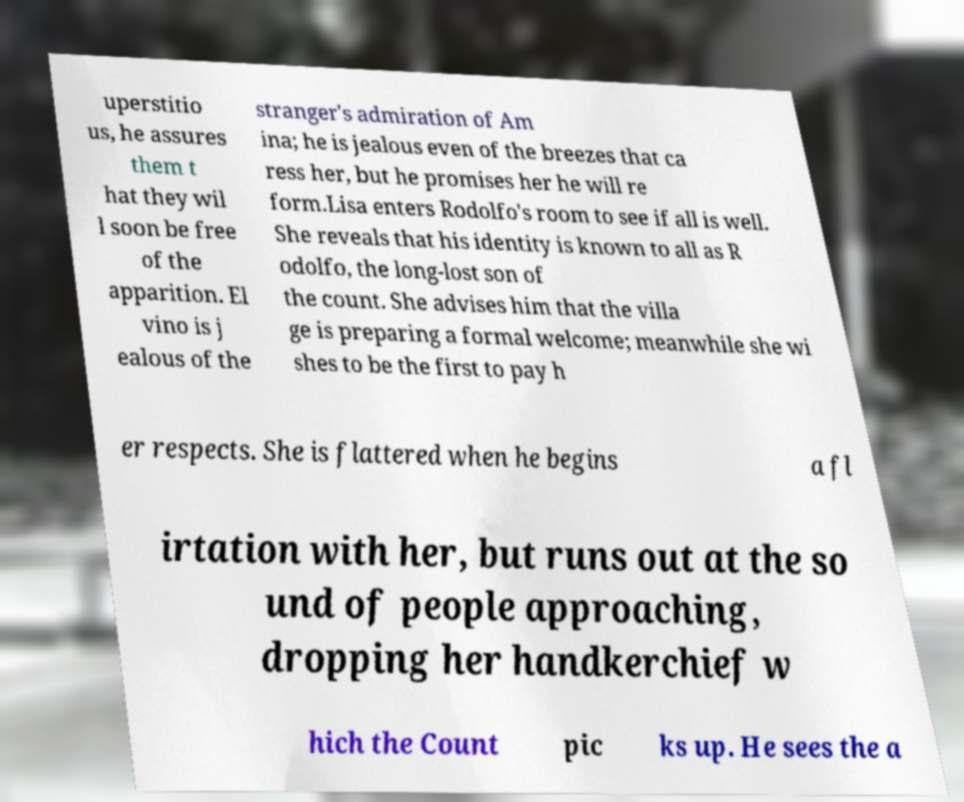Could you extract and type out the text from this image? uperstitio us, he assures them t hat they wil l soon be free of the apparition. El vino is j ealous of the stranger's admiration of Am ina; he is jealous even of the breezes that ca ress her, but he promises her he will re form.Lisa enters Rodolfo's room to see if all is well. She reveals that his identity is known to all as R odolfo, the long-lost son of the count. She advises him that the villa ge is preparing a formal welcome; meanwhile she wi shes to be the first to pay h er respects. She is flattered when he begins a fl irtation with her, but runs out at the so und of people approaching, dropping her handkerchief w hich the Count pic ks up. He sees the a 